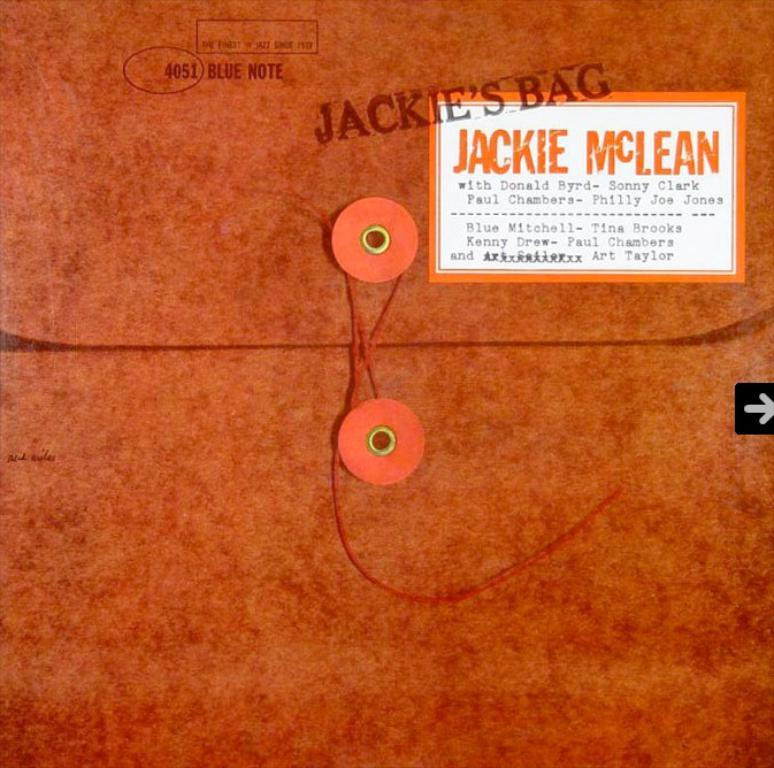<image>
Share a concise interpretation of the image provided. Jackie McLean left her personal documents on the desk. 